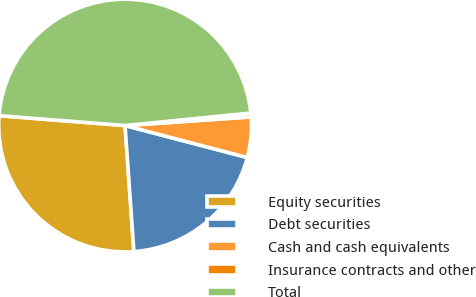<chart> <loc_0><loc_0><loc_500><loc_500><pie_chart><fcel>Equity securities<fcel>Debt securities<fcel>Cash and cash equivalents<fcel>Insurance contracts and other<fcel>Total<nl><fcel>27.36%<fcel>19.81%<fcel>5.16%<fcel>0.49%<fcel>47.17%<nl></chart> 